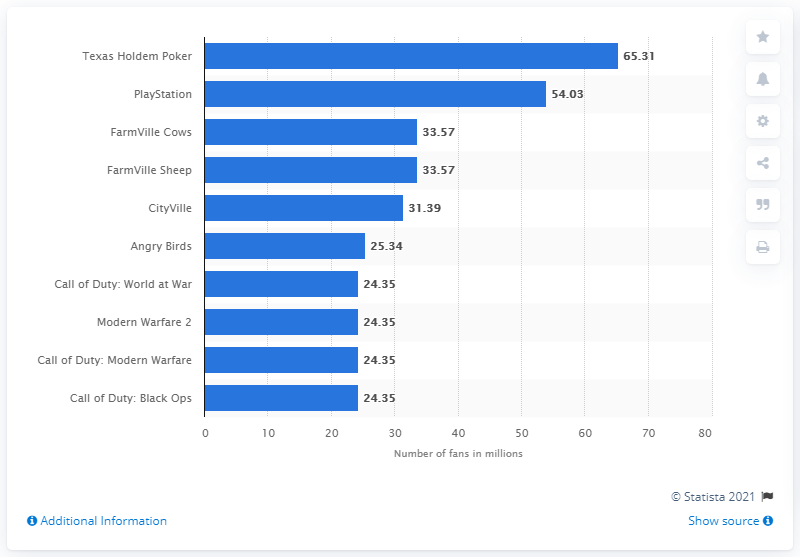Indicate a few pertinent items in this graphic. As of August 2019, Sony had 54,033 Facebook fans. As of February 2023, Zynga's Texas Hold'em Poker had 65.31 million daily active users. 